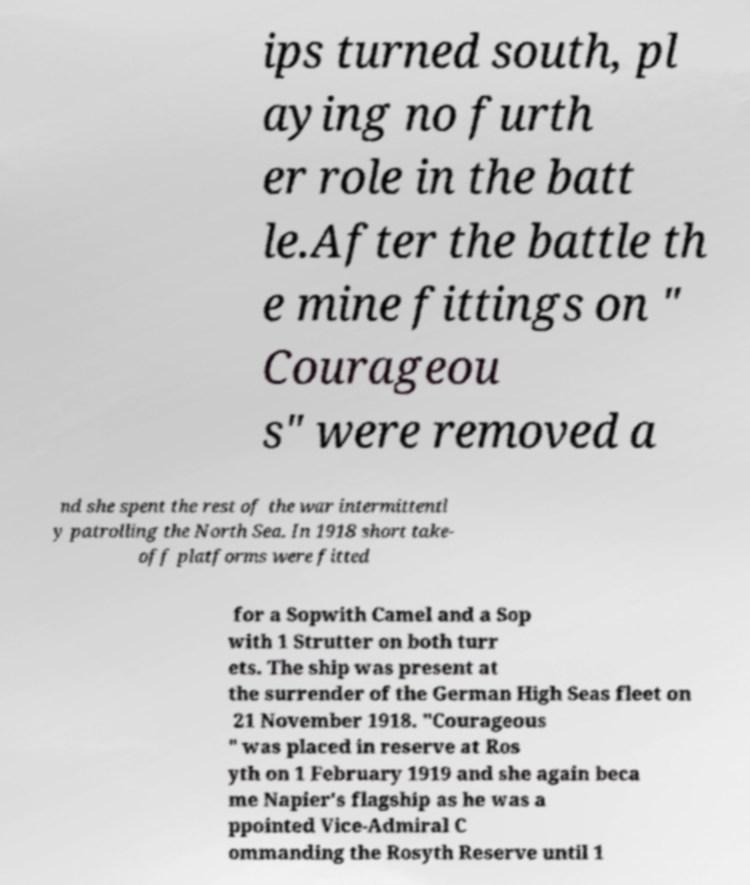There's text embedded in this image that I need extracted. Can you transcribe it verbatim? ips turned south, pl aying no furth er role in the batt le.After the battle th e mine fittings on " Courageou s" were removed a nd she spent the rest of the war intermittentl y patrolling the North Sea. In 1918 short take- off platforms were fitted for a Sopwith Camel and a Sop with 1 Strutter on both turr ets. The ship was present at the surrender of the German High Seas fleet on 21 November 1918. "Courageous " was placed in reserve at Ros yth on 1 February 1919 and she again beca me Napier's flagship as he was a ppointed Vice-Admiral C ommanding the Rosyth Reserve until 1 